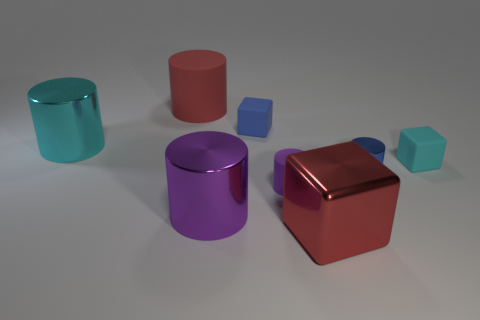What number of rubber cubes have the same color as the large rubber cylinder? 0 